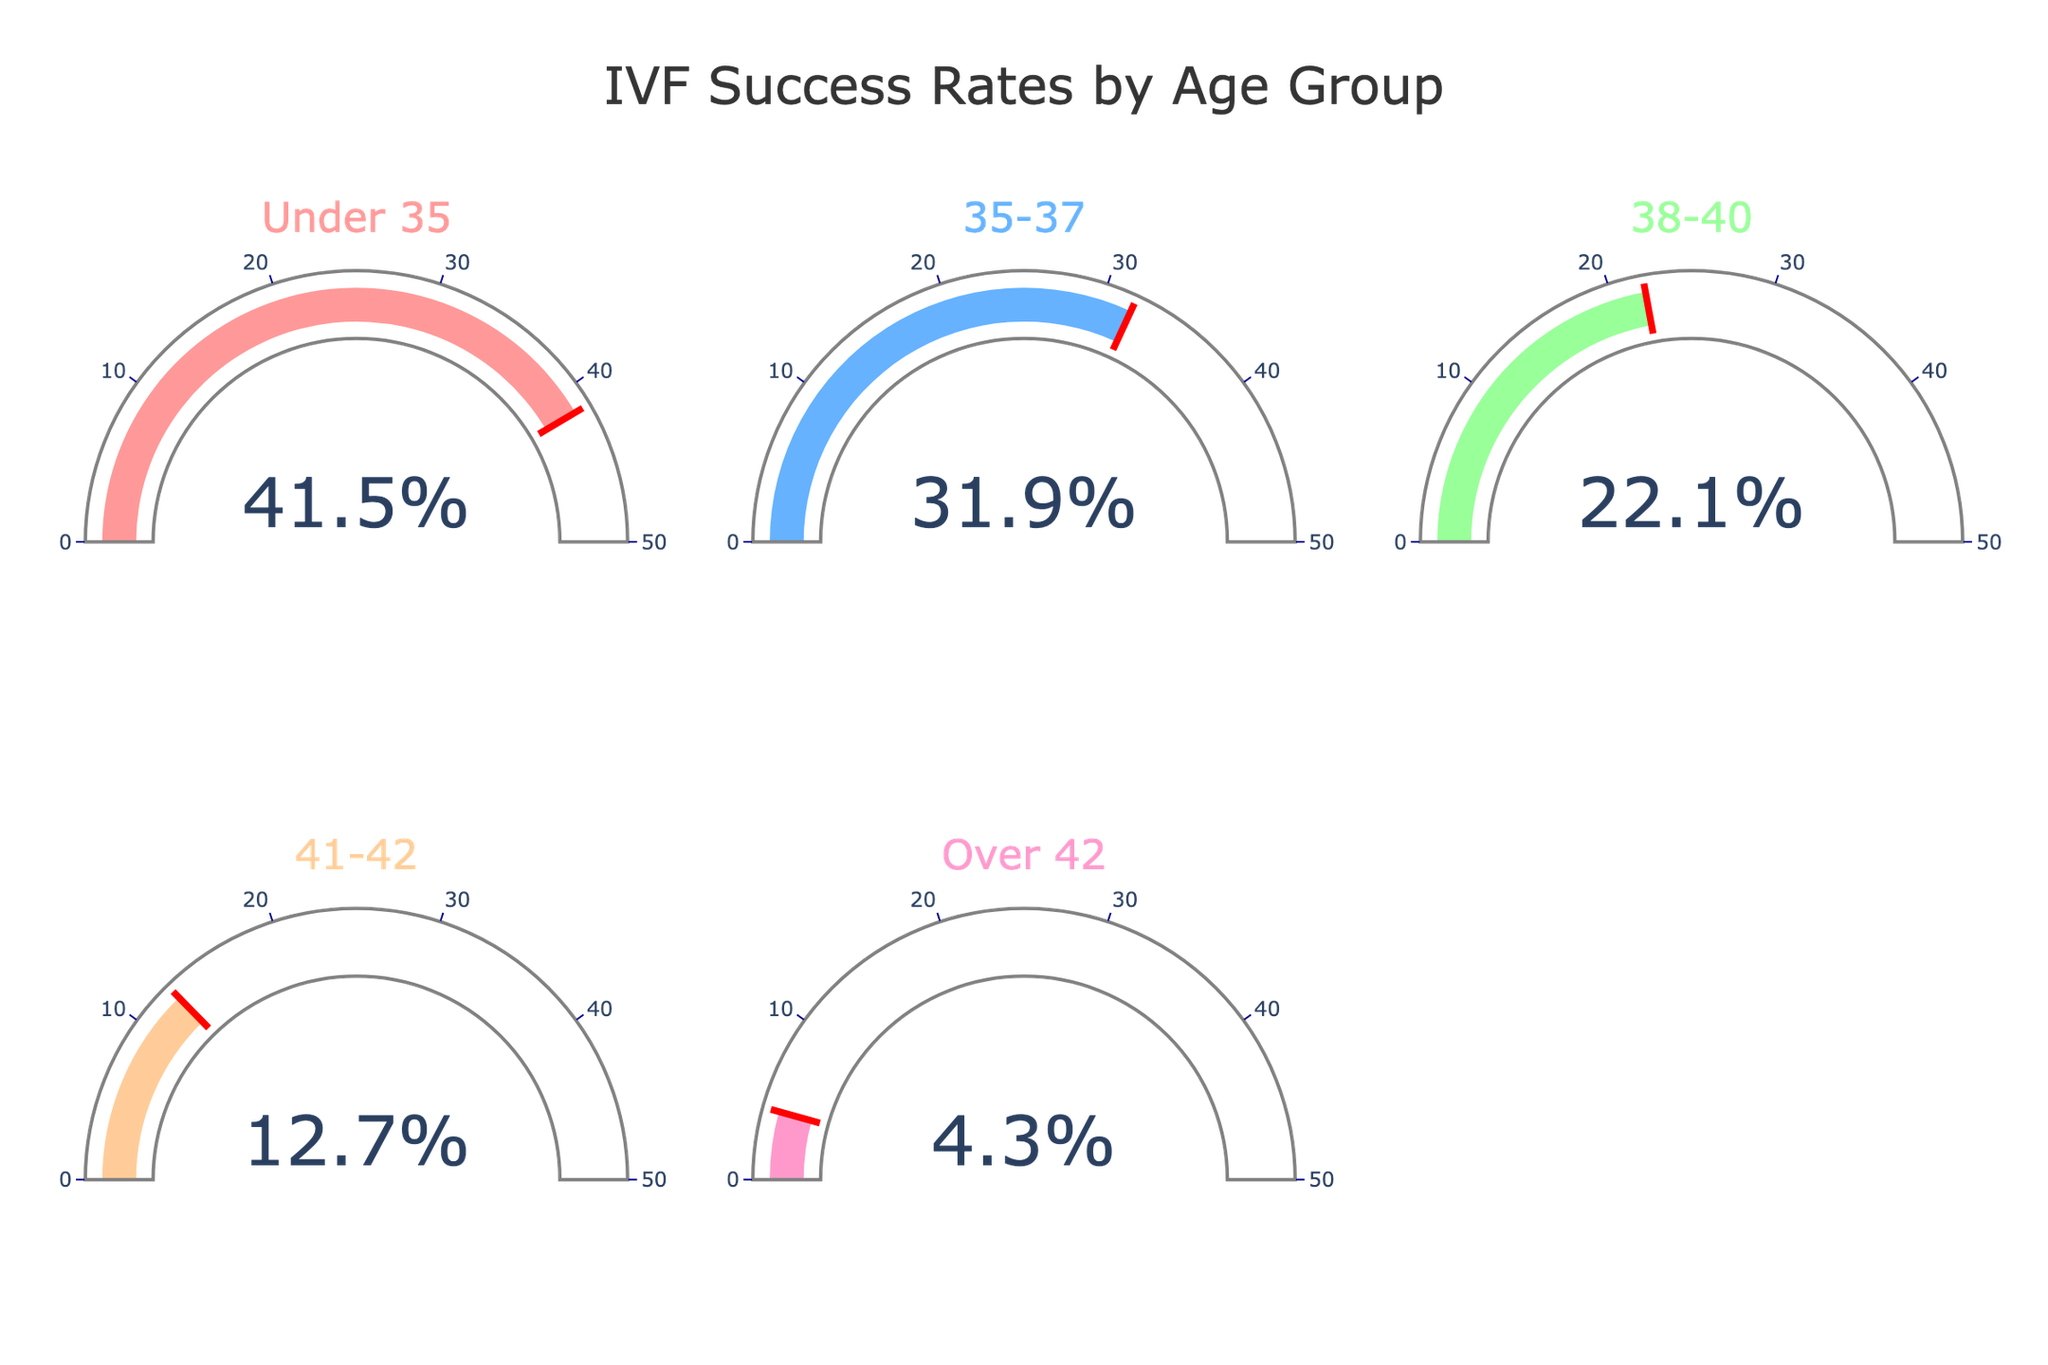What is the success rate for the age group 'Under 35'? The gauge chart for the 'Under 35' age group displays the success rate value.
Answer: 41.5% What is the success rate for the age group 'Over 42'? The gauge chart for the 'Over 42' age group displays the success rate value.
Answer: 4.3% Which age group has the highest success rate? By comparing the values displayed on each gauge, the 'Under 35' age group has the highest success rate.
Answer: Under 35 Which age group has the lowest success rate? By comparing the values displayed on each gauge, the 'Over 42' age group has the lowest success rate.
Answer: Over 42 What is the difference in success rates between the 'Under 35' and '35-37' age groups? Subtract the success rate of the '35-37' age group from the 'Under 35' age group (41.5% - 31.9%).
Answer: 9.6% What is the average success rate for all the age groups? Add all the success rates and divide by the number of age groups: (41.5 + 31.9 + 22.1 + 12.7 + 4.3) / 5.
Answer: 22.5% By how much does the success rate decrease from the 'Under 35' age group to the '38-40' age group? Subtract the success rate of the '38-40' age group from the 'Under 35' age group (41.5% - 22.1%).
Answer: 19.4% Which age group has a success rate closest to 20%? By comparing the success rates, the '38-40' age group has a success rate of 22.1%, which is closest to 20%.
Answer: 38-40 Are there any age groups with a success rate less than 10%? By looking at the gauge values, the 'Over 42' and '41-42' age groups both have success rates less than 10%.
Answer: Yes 